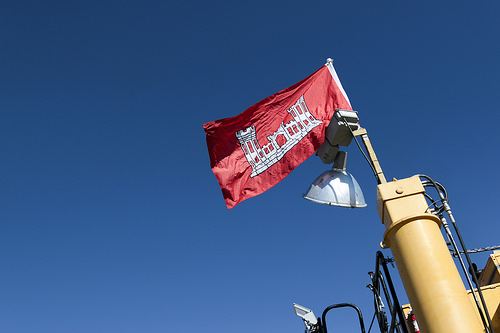<image>
Is the flag on the sky? No. The flag is not positioned on the sky. They may be near each other, but the flag is not supported by or resting on top of the sky. Is there a flag to the right of the light? No. The flag is not to the right of the light. The horizontal positioning shows a different relationship. Is there a flag in front of the sky? Yes. The flag is positioned in front of the sky, appearing closer to the camera viewpoint. 